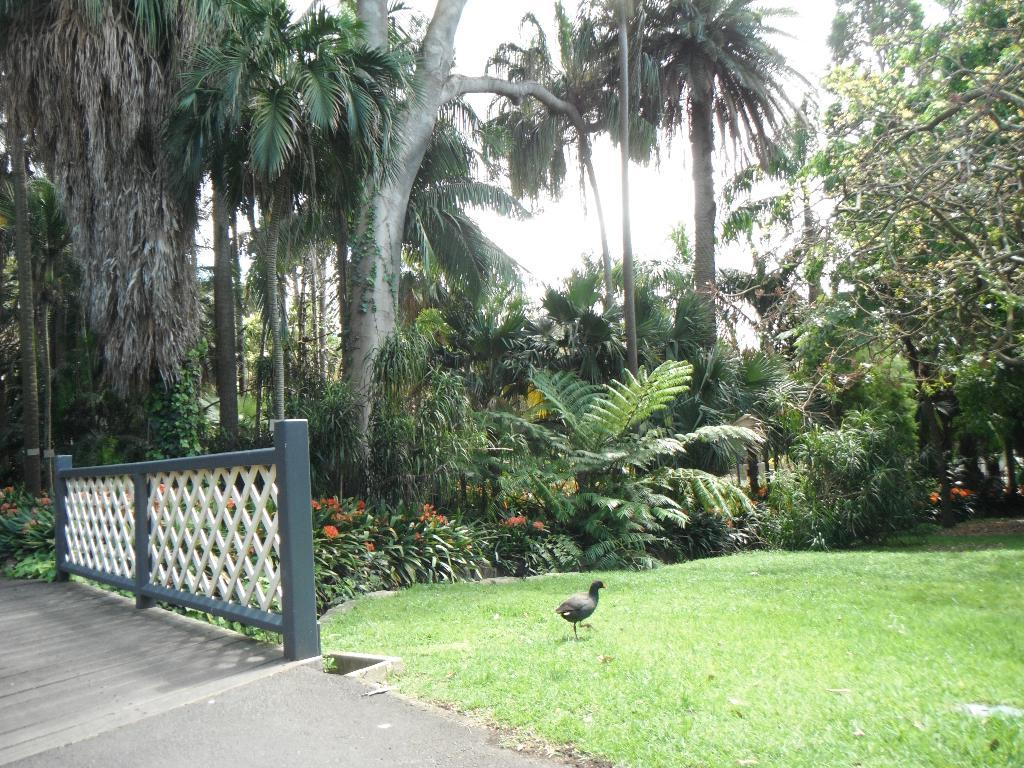What type of animal can be seen in the image? There is a bird in the image. What is the bird doing in the image? The bird is walking on the grass. What can be seen in the background of the image? There are trees, plants, and the sky visible in the background of the image. What type of structure is present in the image? There is a fence in the image. What type of bead is the bird using to write on the wood in the image? There is no bead or wood present in the image, and the bird is not writing on anything. What type of quill is the bird holding in the image? There is no quill present in the image, and the bird is not holding anything. 